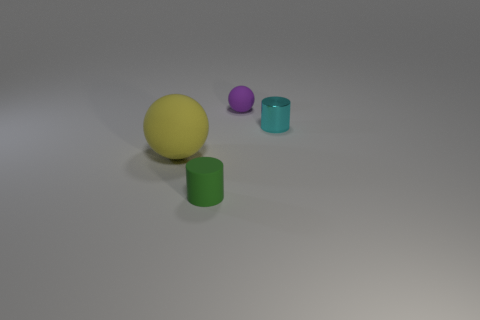How many objects are big spheres or matte things behind the shiny cylinder?
Ensure brevity in your answer.  2. The yellow object that is the same shape as the purple rubber object is what size?
Keep it short and to the point. Large. Is there any other thing that has the same size as the metallic thing?
Give a very brief answer. Yes. There is a purple rubber object; are there any small cylinders to the right of it?
Provide a succinct answer. Yes. There is a cylinder that is left of the tiny sphere; is its color the same as the object that is left of the green cylinder?
Your answer should be very brief. No. Is there a small green thing that has the same shape as the purple rubber object?
Your response must be concise. No. How many other objects are the same color as the big rubber thing?
Your answer should be very brief. 0. What is the color of the matte sphere that is behind the sphere that is left of the ball that is on the right side of the yellow thing?
Your response must be concise. Purple. Is the number of tiny matte spheres that are in front of the small rubber cylinder the same as the number of big yellow matte spheres?
Provide a short and direct response. No. Is the size of the rubber ball that is to the right of the green rubber cylinder the same as the cyan metallic cylinder?
Your response must be concise. Yes. 